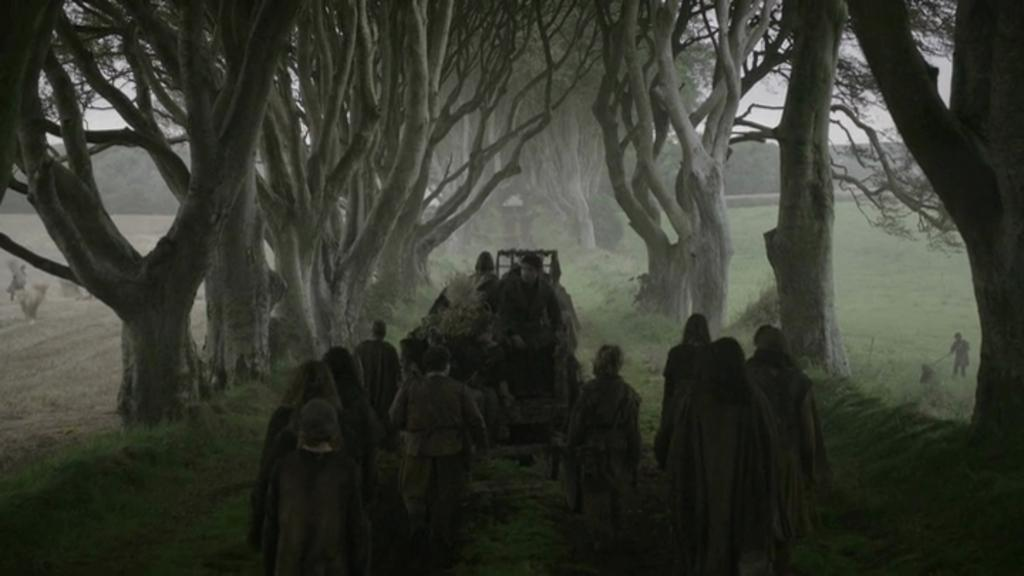How many people are in the image? There is a group of people in the image, but the exact number cannot be determined from the provided facts. What type of vehicle is in the image? There is a vehicle in the image, but the specific type cannot be determined from the provided facts. What type of vegetation is present in the image? There are plants and trees in the image. What is visible in the background of the image? The sky is visible in the background of the image. How many seats are available in the vehicle in the image? There is no information about the number of seats in the vehicle in the image. What type of chairs are present in the image? There is no mention of chairs in the image. 